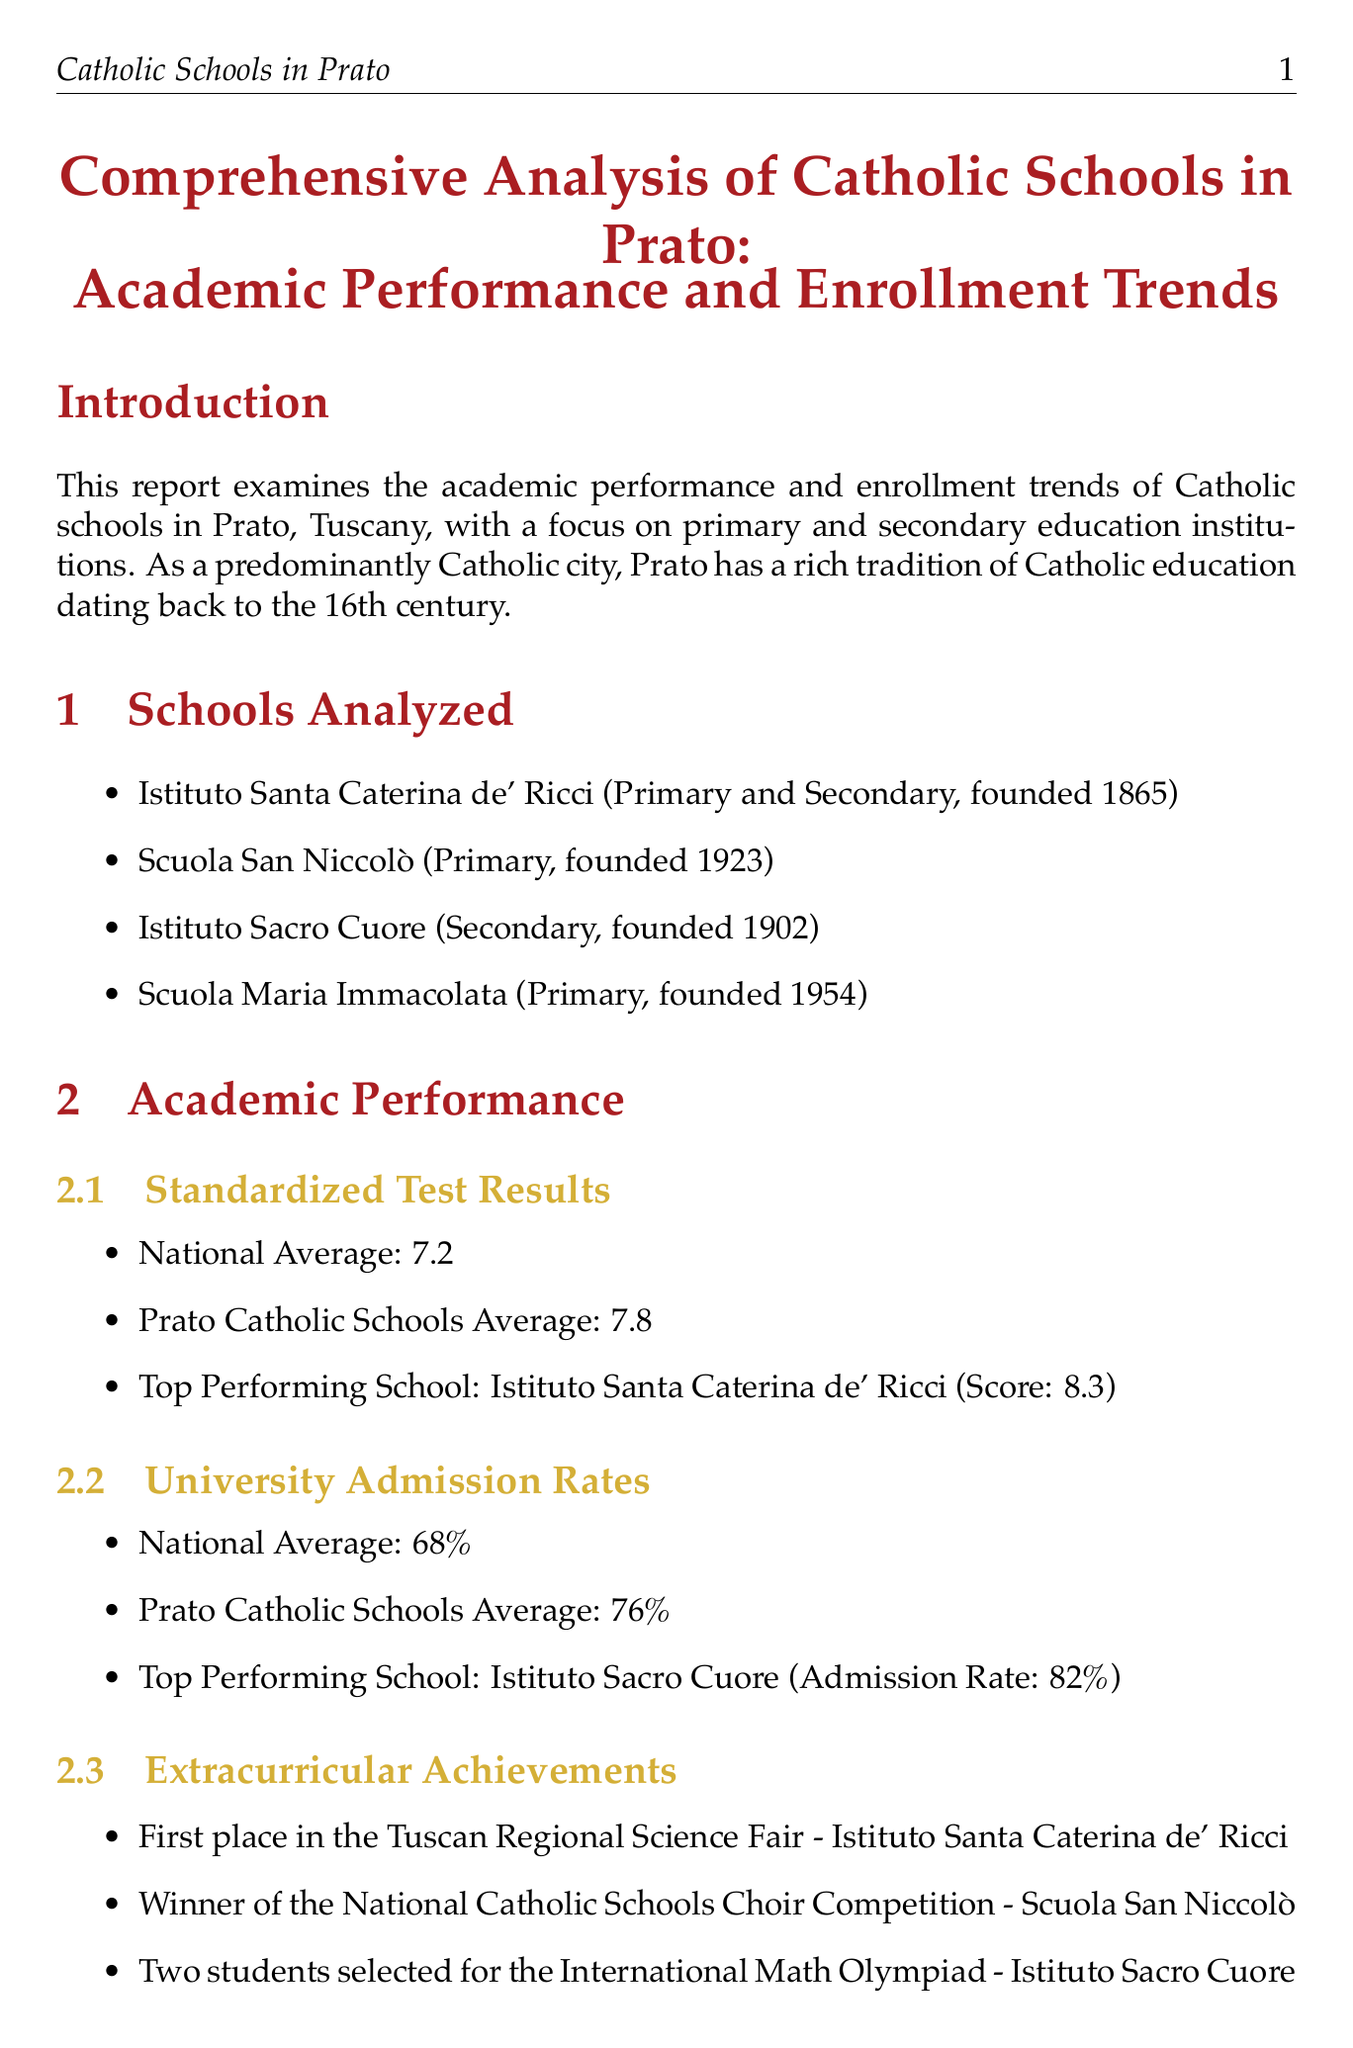What is the title of the report? The title of the report is presented at the beginning of the document.
Answer: Comprehensive Analysis of Catholic Schools in Prato: Academic Performance and Enrollment Trends What is the top-performing school in standardized test results? The top-performing school is mentioned in the academic performance section of the report.
Answer: Istituto Santa Caterina de' Ricci What was the total enrollment in 2022? The total enrollment figure for 2022 is included in the enrollment trends data.
Answer: 2290 What percentage is the university admission rate for Prato Catholic schools? The university admission rate for Prato Catholic schools is given in the admission rates section.
Answer: 76% What challenges do Catholic schools in Prato face? The report lists specific challenges in a detailed section.
Answer: Maintaining affordability for local families What extracurricular achievement did Scuola San Niccolò achieve? Extracurricular achievements are highlighted in the academic performance section.
Answer: Winner of the National Catholic Schools Choir Competition What trend has been observed in enrollment over the past five years? The overall trend in enrollment is mentioned in the enrollment trends section.
Answer: Slight increase What factor influences enrollment positively? A list of factors influencing enrollment is provided in the report.
Answer: Strong academic reputation How many schools were analyzed in the report? The number of schools is explicitly listed in the schools analyzed section.
Answer: Four 